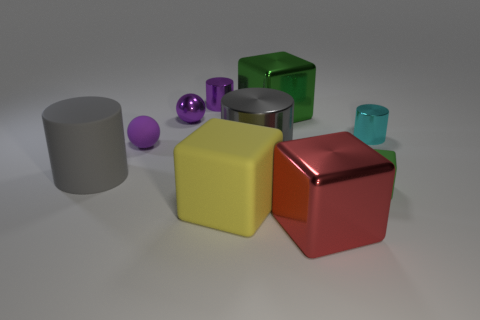Subtract 1 cylinders. How many cylinders are left? 3 Subtract all gray blocks. Subtract all red spheres. How many blocks are left? 4 Subtract all cubes. How many objects are left? 6 Subtract all brown things. Subtract all gray metallic cylinders. How many objects are left? 9 Add 3 metallic objects. How many metallic objects are left? 9 Add 7 small cubes. How many small cubes exist? 8 Subtract 0 blue cubes. How many objects are left? 10 